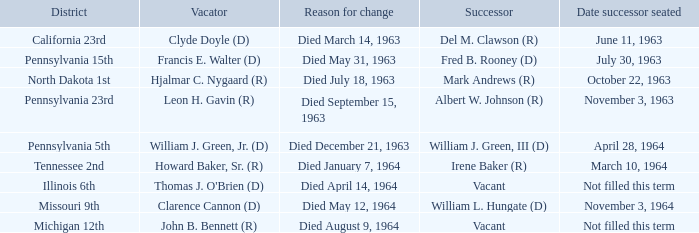Who are all successors when reason for change is died May 12, 1964? William L. Hungate (D). 